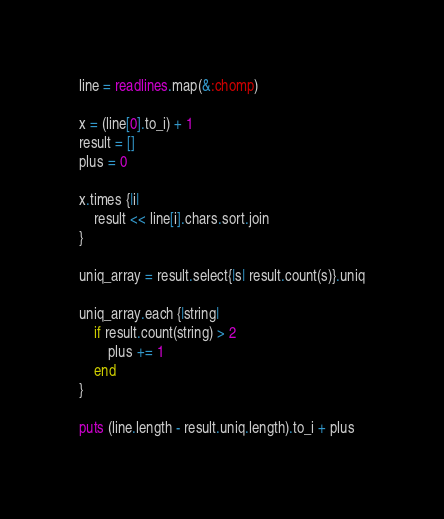Convert code to text. <code><loc_0><loc_0><loc_500><loc_500><_Ruby_>line = readlines.map(&:chomp)

x = (line[0].to_i) + 1
result = []
plus = 0

x.times {|i|
    result << line[i].chars.sort.join
}

uniq_array = result.select{|s| result.count(s)}.uniq

uniq_array.each {|string|
    if result.count(string) > 2
        plus += 1
    end
}

puts (line.length - result.uniq.length).to_i + plus</code> 